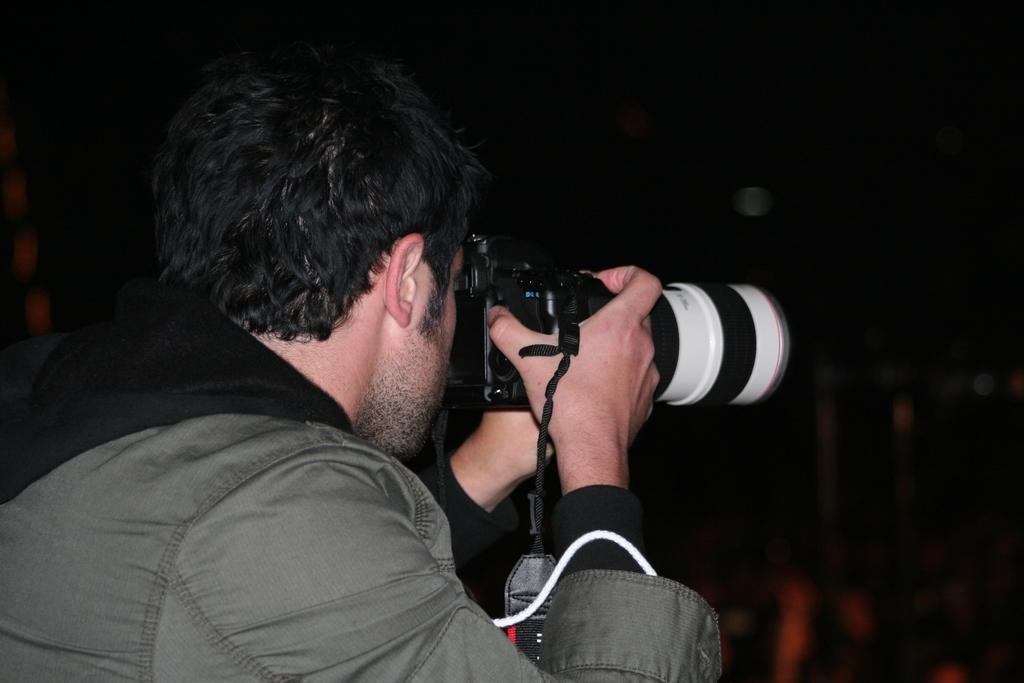What is the main subject of the image? There is a person in the image. What is the person holding in the image? The person is holding a camera. What is the person doing with the camera? The person is clicking a picture with the camera. What type of whip is the person using to take the picture in the image? There is no whip present in the image; the person is using a camera to take a picture. 